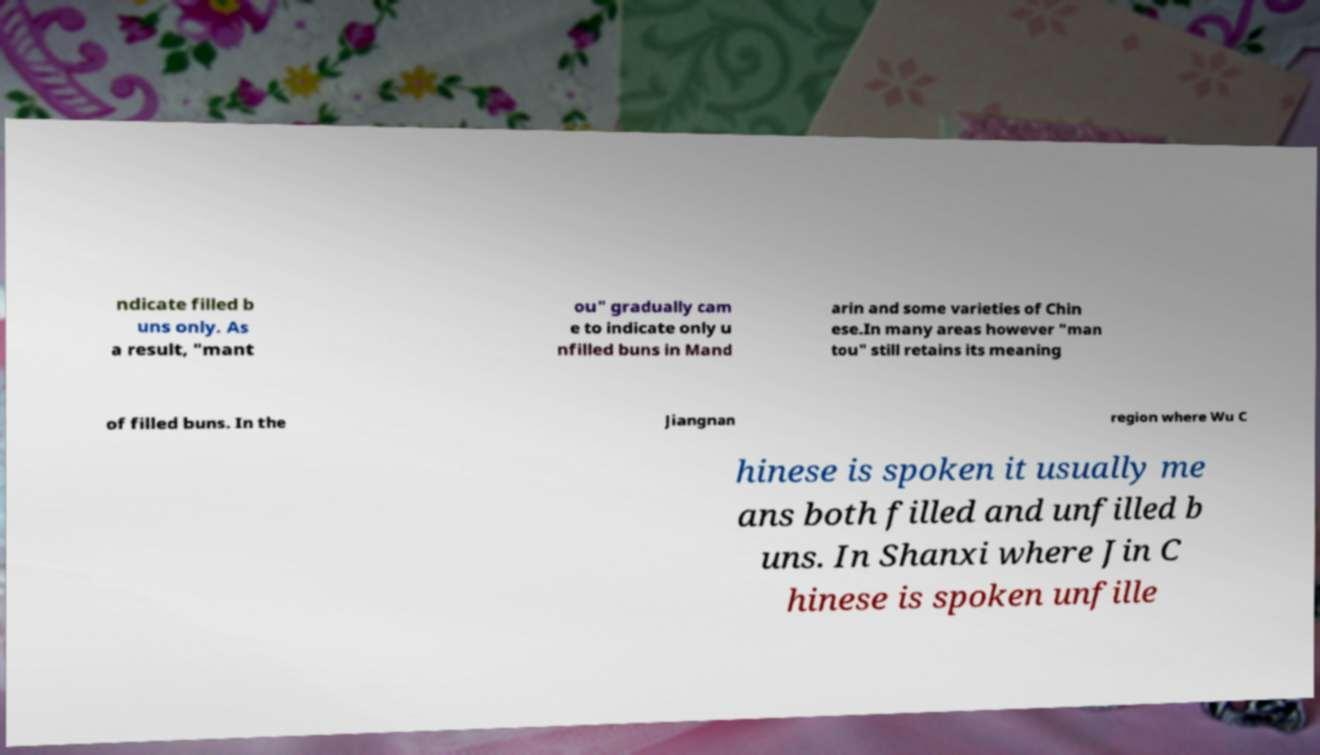There's text embedded in this image that I need extracted. Can you transcribe it verbatim? ndicate filled b uns only. As a result, "mant ou" gradually cam e to indicate only u nfilled buns in Mand arin and some varieties of Chin ese.In many areas however "man tou" still retains its meaning of filled buns. In the Jiangnan region where Wu C hinese is spoken it usually me ans both filled and unfilled b uns. In Shanxi where Jin C hinese is spoken unfille 